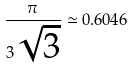Convert formula to latex. <formula><loc_0><loc_0><loc_500><loc_500>\frac { \pi } { 3 \sqrt { 3 } } \simeq 0 . 6 0 4 6</formula> 